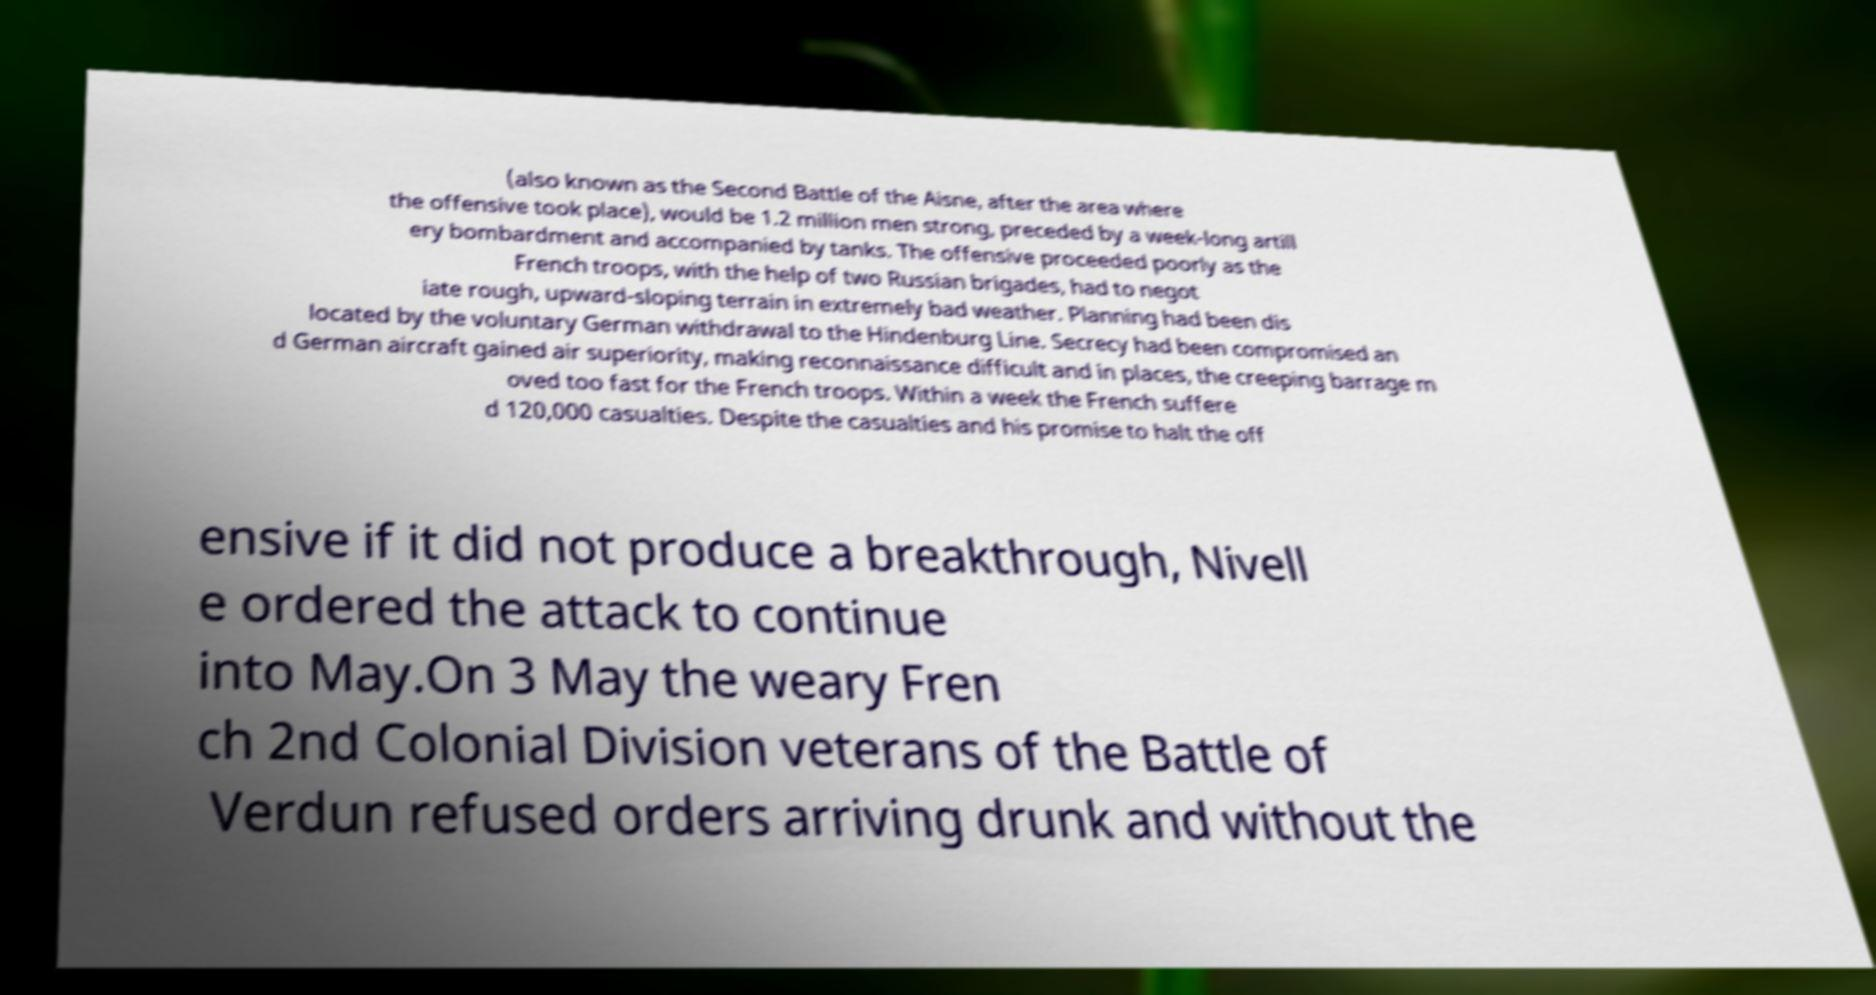What messages or text are displayed in this image? I need them in a readable, typed format. (also known as the Second Battle of the Aisne, after the area where the offensive took place), would be 1.2 million men strong, preceded by a week-long artill ery bombardment and accompanied by tanks. The offensive proceeded poorly as the French troops, with the help of two Russian brigades, had to negot iate rough, upward-sloping terrain in extremely bad weather. Planning had been dis located by the voluntary German withdrawal to the Hindenburg Line. Secrecy had been compromised an d German aircraft gained air superiority, making reconnaissance difficult and in places, the creeping barrage m oved too fast for the French troops. Within a week the French suffere d 120,000 casualties. Despite the casualties and his promise to halt the off ensive if it did not produce a breakthrough, Nivell e ordered the attack to continue into May.On 3 May the weary Fren ch 2nd Colonial Division veterans of the Battle of Verdun refused orders arriving drunk and without the 